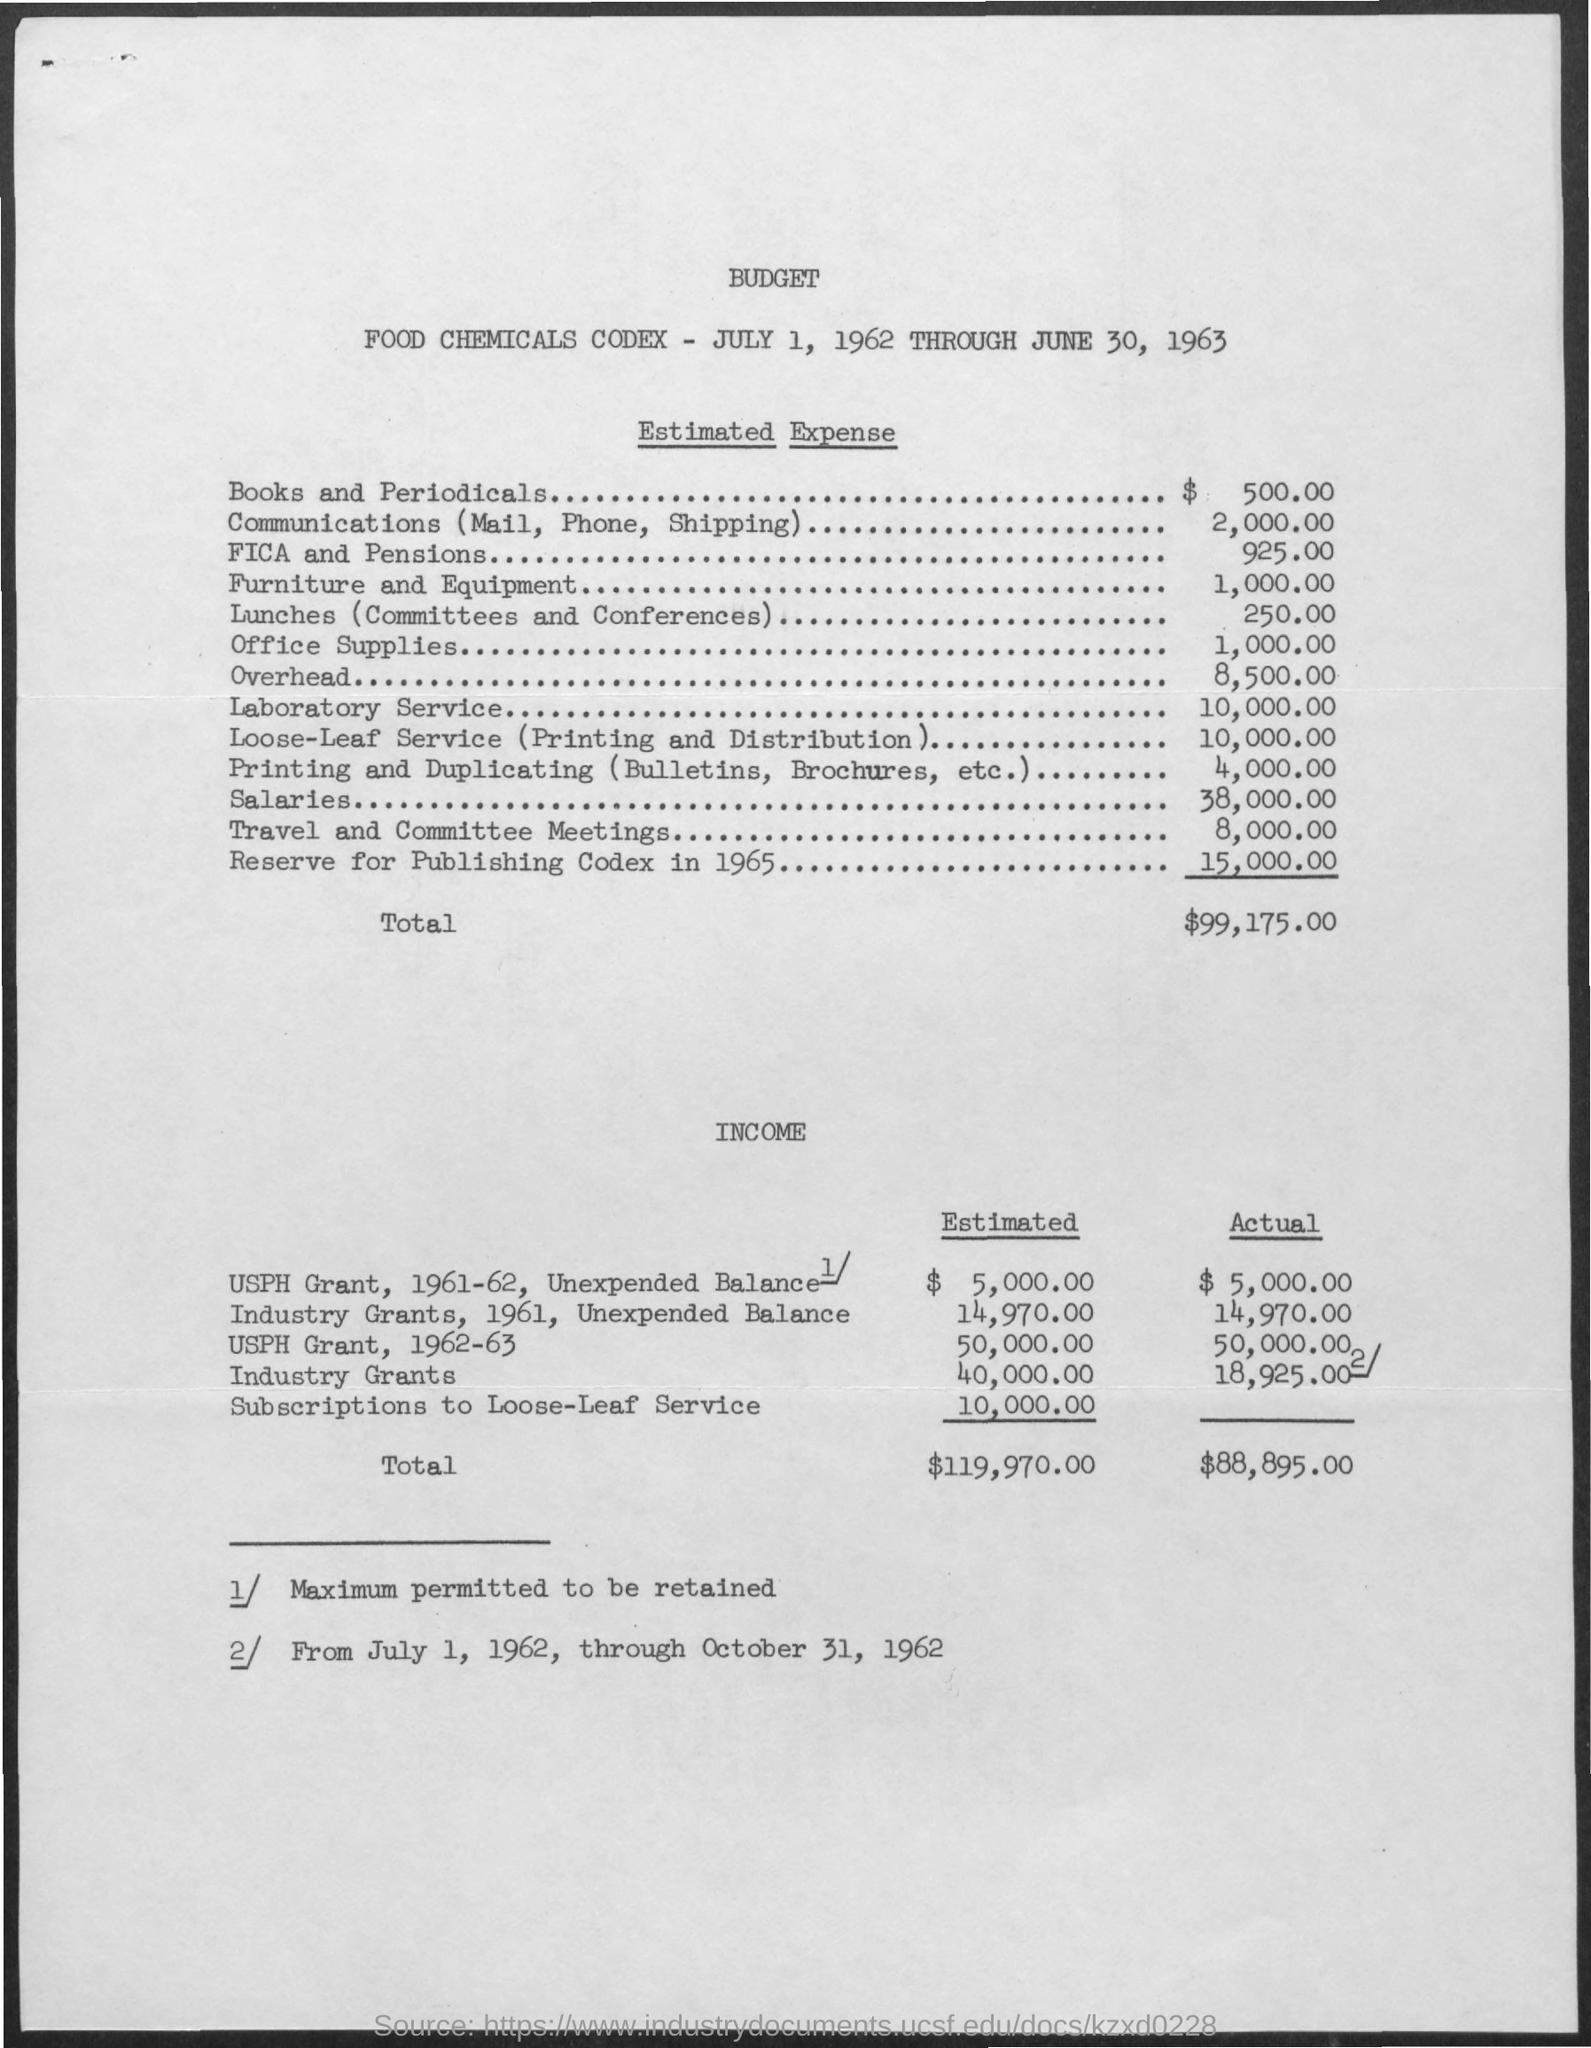List a handful of essential elements in this visual. The budget's tenure is from JULY 1, 1962, through JUNE 30, 1963. 